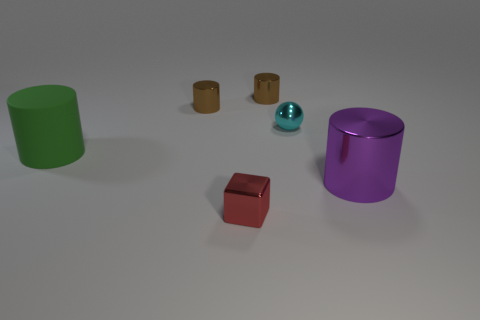Are there any other things that are made of the same material as the big green thing?
Make the answer very short. No. The other matte object that is the same shape as the purple thing is what size?
Offer a terse response. Large. Does the big green cylinder have the same material as the big object in front of the matte cylinder?
Provide a succinct answer. No. Is the shape of the large green rubber thing the same as the small brown thing to the right of the block?
Your answer should be compact. Yes. There is a object in front of the large thing that is in front of the large object on the left side of the large metallic object; what is its color?
Offer a very short reply. Red. Are there any large rubber cylinders in front of the green rubber object?
Offer a very short reply. No. Is there a small blue cube that has the same material as the large purple cylinder?
Make the answer very short. No. What color is the tiny block?
Give a very brief answer. Red. There is a tiny metallic object that is in front of the big rubber cylinder; is it the same shape as the tiny cyan thing?
Your answer should be very brief. No. There is a small brown metal thing to the left of the metallic object in front of the big object right of the red metallic object; what shape is it?
Ensure brevity in your answer.  Cylinder. 